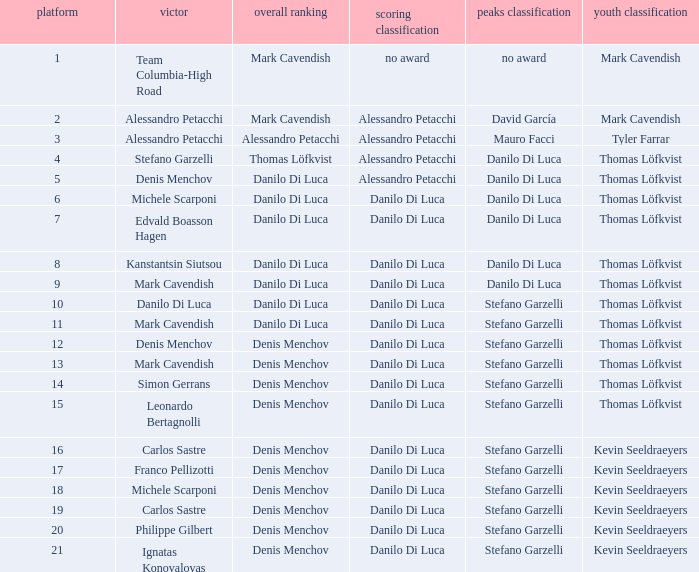Who is the leader in the points classification during stage 19? Danilo Di Luca. 